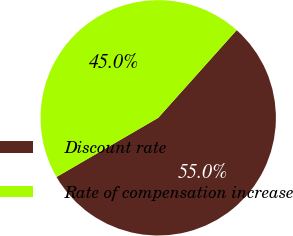<chart> <loc_0><loc_0><loc_500><loc_500><pie_chart><fcel>Discount rate<fcel>Rate of compensation increase<nl><fcel>55.0%<fcel>45.0%<nl></chart> 